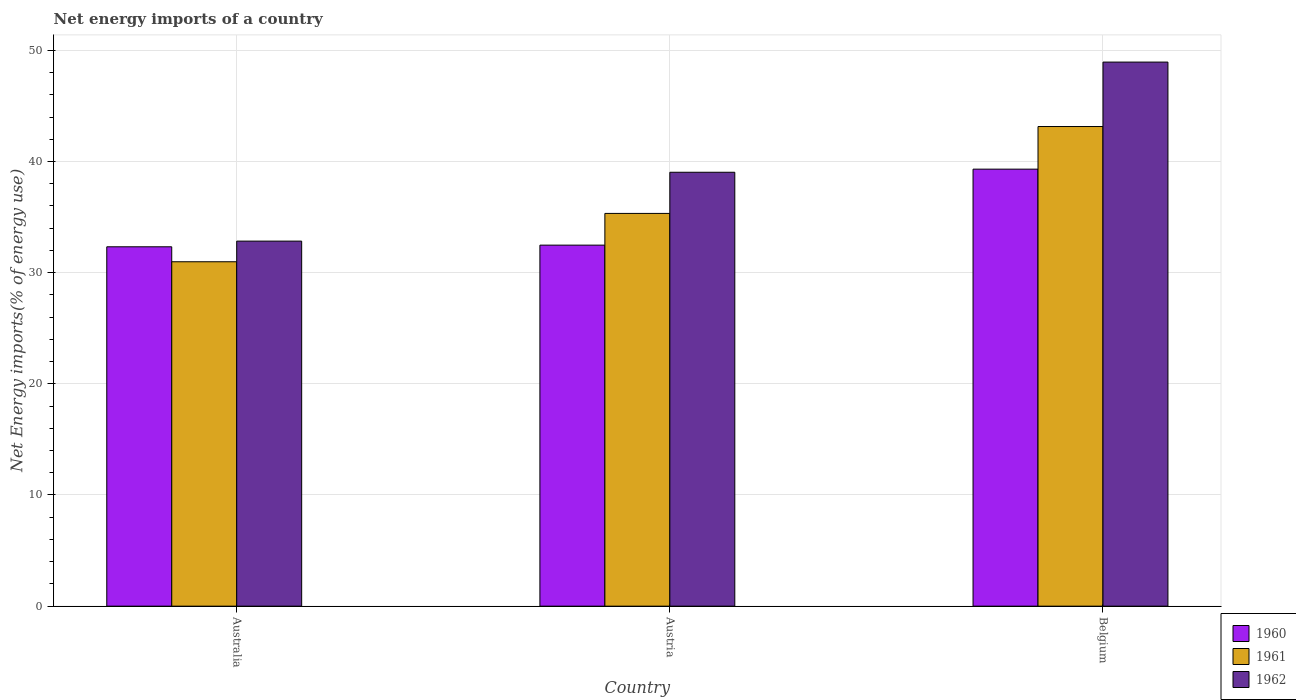How many groups of bars are there?
Give a very brief answer. 3. How many bars are there on the 2nd tick from the left?
Your response must be concise. 3. What is the net energy imports in 1962 in Australia?
Make the answer very short. 32.84. Across all countries, what is the maximum net energy imports in 1962?
Make the answer very short. 48.94. Across all countries, what is the minimum net energy imports in 1960?
Keep it short and to the point. 32.33. In which country was the net energy imports in 1961 minimum?
Provide a short and direct response. Australia. What is the total net energy imports in 1962 in the graph?
Offer a very short reply. 120.81. What is the difference between the net energy imports in 1962 in Austria and that in Belgium?
Provide a short and direct response. -9.91. What is the difference between the net energy imports in 1960 in Australia and the net energy imports in 1961 in Belgium?
Your answer should be compact. -10.82. What is the average net energy imports in 1961 per country?
Provide a short and direct response. 36.48. What is the difference between the net energy imports of/in 1961 and net energy imports of/in 1962 in Austria?
Offer a very short reply. -3.7. In how many countries, is the net energy imports in 1962 greater than 46 %?
Provide a short and direct response. 1. What is the ratio of the net energy imports in 1962 in Australia to that in Belgium?
Your answer should be compact. 0.67. What is the difference between the highest and the second highest net energy imports in 1962?
Your response must be concise. 16.1. What is the difference between the highest and the lowest net energy imports in 1960?
Your response must be concise. 6.98. Is the sum of the net energy imports in 1961 in Australia and Belgium greater than the maximum net energy imports in 1960 across all countries?
Give a very brief answer. Yes. How many bars are there?
Make the answer very short. 9. How many countries are there in the graph?
Ensure brevity in your answer.  3. Are the values on the major ticks of Y-axis written in scientific E-notation?
Offer a terse response. No. Does the graph contain any zero values?
Your answer should be very brief. No. How are the legend labels stacked?
Your response must be concise. Vertical. What is the title of the graph?
Make the answer very short. Net energy imports of a country. What is the label or title of the X-axis?
Ensure brevity in your answer.  Country. What is the label or title of the Y-axis?
Provide a succinct answer. Net Energy imports(% of energy use). What is the Net Energy imports(% of energy use) of 1960 in Australia?
Your response must be concise. 32.33. What is the Net Energy imports(% of energy use) in 1961 in Australia?
Offer a terse response. 30.98. What is the Net Energy imports(% of energy use) of 1962 in Australia?
Your answer should be very brief. 32.84. What is the Net Energy imports(% of energy use) in 1960 in Austria?
Make the answer very short. 32.48. What is the Net Energy imports(% of energy use) of 1961 in Austria?
Give a very brief answer. 35.33. What is the Net Energy imports(% of energy use) of 1962 in Austria?
Your answer should be compact. 39.03. What is the Net Energy imports(% of energy use) in 1960 in Belgium?
Provide a short and direct response. 39.31. What is the Net Energy imports(% of energy use) in 1961 in Belgium?
Offer a terse response. 43.14. What is the Net Energy imports(% of energy use) of 1962 in Belgium?
Offer a very short reply. 48.94. Across all countries, what is the maximum Net Energy imports(% of energy use) in 1960?
Offer a very short reply. 39.31. Across all countries, what is the maximum Net Energy imports(% of energy use) of 1961?
Offer a very short reply. 43.14. Across all countries, what is the maximum Net Energy imports(% of energy use) of 1962?
Offer a terse response. 48.94. Across all countries, what is the minimum Net Energy imports(% of energy use) in 1960?
Give a very brief answer. 32.33. Across all countries, what is the minimum Net Energy imports(% of energy use) of 1961?
Make the answer very short. 30.98. Across all countries, what is the minimum Net Energy imports(% of energy use) of 1962?
Ensure brevity in your answer.  32.84. What is the total Net Energy imports(% of energy use) in 1960 in the graph?
Ensure brevity in your answer.  104.11. What is the total Net Energy imports(% of energy use) of 1961 in the graph?
Provide a succinct answer. 109.45. What is the total Net Energy imports(% of energy use) of 1962 in the graph?
Your answer should be compact. 120.81. What is the difference between the Net Energy imports(% of energy use) of 1960 in Australia and that in Austria?
Ensure brevity in your answer.  -0.15. What is the difference between the Net Energy imports(% of energy use) of 1961 in Australia and that in Austria?
Provide a short and direct response. -4.35. What is the difference between the Net Energy imports(% of energy use) in 1962 in Australia and that in Austria?
Keep it short and to the point. -6.19. What is the difference between the Net Energy imports(% of energy use) of 1960 in Australia and that in Belgium?
Make the answer very short. -6.98. What is the difference between the Net Energy imports(% of energy use) in 1961 in Australia and that in Belgium?
Give a very brief answer. -12.16. What is the difference between the Net Energy imports(% of energy use) of 1962 in Australia and that in Belgium?
Make the answer very short. -16.1. What is the difference between the Net Energy imports(% of energy use) of 1960 in Austria and that in Belgium?
Offer a very short reply. -6.83. What is the difference between the Net Energy imports(% of energy use) of 1961 in Austria and that in Belgium?
Ensure brevity in your answer.  -7.82. What is the difference between the Net Energy imports(% of energy use) of 1962 in Austria and that in Belgium?
Offer a terse response. -9.91. What is the difference between the Net Energy imports(% of energy use) in 1960 in Australia and the Net Energy imports(% of energy use) in 1961 in Austria?
Provide a succinct answer. -3. What is the difference between the Net Energy imports(% of energy use) in 1960 in Australia and the Net Energy imports(% of energy use) in 1962 in Austria?
Make the answer very short. -6.7. What is the difference between the Net Energy imports(% of energy use) in 1961 in Australia and the Net Energy imports(% of energy use) in 1962 in Austria?
Provide a short and direct response. -8.05. What is the difference between the Net Energy imports(% of energy use) in 1960 in Australia and the Net Energy imports(% of energy use) in 1961 in Belgium?
Provide a succinct answer. -10.82. What is the difference between the Net Energy imports(% of energy use) of 1960 in Australia and the Net Energy imports(% of energy use) of 1962 in Belgium?
Provide a short and direct response. -16.61. What is the difference between the Net Energy imports(% of energy use) of 1961 in Australia and the Net Energy imports(% of energy use) of 1962 in Belgium?
Your answer should be compact. -17.96. What is the difference between the Net Energy imports(% of energy use) in 1960 in Austria and the Net Energy imports(% of energy use) in 1961 in Belgium?
Offer a terse response. -10.67. What is the difference between the Net Energy imports(% of energy use) of 1960 in Austria and the Net Energy imports(% of energy use) of 1962 in Belgium?
Offer a very short reply. -16.46. What is the difference between the Net Energy imports(% of energy use) of 1961 in Austria and the Net Energy imports(% of energy use) of 1962 in Belgium?
Provide a succinct answer. -13.61. What is the average Net Energy imports(% of energy use) in 1960 per country?
Your answer should be compact. 34.7. What is the average Net Energy imports(% of energy use) in 1961 per country?
Your response must be concise. 36.48. What is the average Net Energy imports(% of energy use) of 1962 per country?
Make the answer very short. 40.27. What is the difference between the Net Energy imports(% of energy use) of 1960 and Net Energy imports(% of energy use) of 1961 in Australia?
Keep it short and to the point. 1.35. What is the difference between the Net Energy imports(% of energy use) of 1960 and Net Energy imports(% of energy use) of 1962 in Australia?
Ensure brevity in your answer.  -0.51. What is the difference between the Net Energy imports(% of energy use) in 1961 and Net Energy imports(% of energy use) in 1962 in Australia?
Ensure brevity in your answer.  -1.86. What is the difference between the Net Energy imports(% of energy use) of 1960 and Net Energy imports(% of energy use) of 1961 in Austria?
Provide a short and direct response. -2.85. What is the difference between the Net Energy imports(% of energy use) of 1960 and Net Energy imports(% of energy use) of 1962 in Austria?
Offer a terse response. -6.55. What is the difference between the Net Energy imports(% of energy use) in 1961 and Net Energy imports(% of energy use) in 1962 in Austria?
Keep it short and to the point. -3.7. What is the difference between the Net Energy imports(% of energy use) of 1960 and Net Energy imports(% of energy use) of 1961 in Belgium?
Ensure brevity in your answer.  -3.83. What is the difference between the Net Energy imports(% of energy use) of 1960 and Net Energy imports(% of energy use) of 1962 in Belgium?
Keep it short and to the point. -9.63. What is the difference between the Net Energy imports(% of energy use) of 1961 and Net Energy imports(% of energy use) of 1962 in Belgium?
Offer a very short reply. -5.8. What is the ratio of the Net Energy imports(% of energy use) of 1961 in Australia to that in Austria?
Your answer should be very brief. 0.88. What is the ratio of the Net Energy imports(% of energy use) of 1962 in Australia to that in Austria?
Your answer should be very brief. 0.84. What is the ratio of the Net Energy imports(% of energy use) in 1960 in Australia to that in Belgium?
Your answer should be compact. 0.82. What is the ratio of the Net Energy imports(% of energy use) in 1961 in Australia to that in Belgium?
Offer a terse response. 0.72. What is the ratio of the Net Energy imports(% of energy use) in 1962 in Australia to that in Belgium?
Offer a terse response. 0.67. What is the ratio of the Net Energy imports(% of energy use) of 1960 in Austria to that in Belgium?
Provide a short and direct response. 0.83. What is the ratio of the Net Energy imports(% of energy use) of 1961 in Austria to that in Belgium?
Make the answer very short. 0.82. What is the ratio of the Net Energy imports(% of energy use) of 1962 in Austria to that in Belgium?
Your answer should be very brief. 0.8. What is the difference between the highest and the second highest Net Energy imports(% of energy use) in 1960?
Ensure brevity in your answer.  6.83. What is the difference between the highest and the second highest Net Energy imports(% of energy use) in 1961?
Keep it short and to the point. 7.82. What is the difference between the highest and the second highest Net Energy imports(% of energy use) of 1962?
Make the answer very short. 9.91. What is the difference between the highest and the lowest Net Energy imports(% of energy use) in 1960?
Give a very brief answer. 6.98. What is the difference between the highest and the lowest Net Energy imports(% of energy use) of 1961?
Give a very brief answer. 12.16. What is the difference between the highest and the lowest Net Energy imports(% of energy use) in 1962?
Your answer should be very brief. 16.1. 